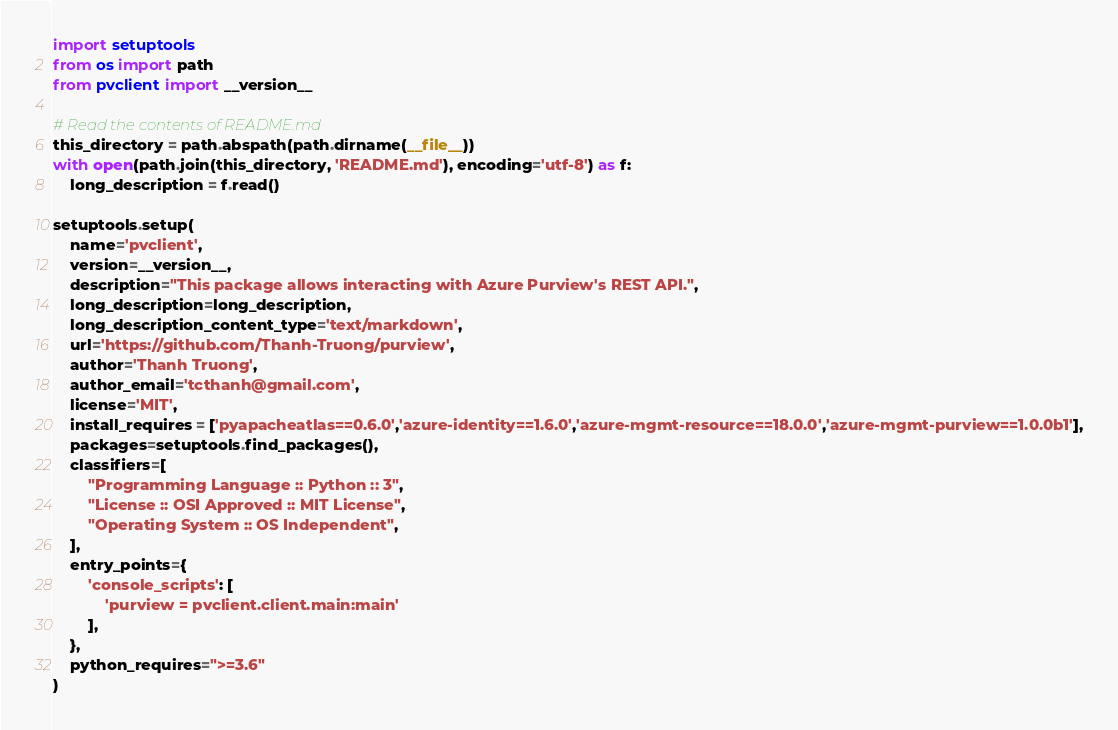<code> <loc_0><loc_0><loc_500><loc_500><_Python_>import setuptools
from os import path
from pvclient import __version__

# Read the contents of README.md
this_directory = path.abspath(path.dirname(__file__))
with open(path.join(this_directory, 'README.md'), encoding='utf-8') as f:
    long_description = f.read()

setuptools.setup(
    name='pvclient',
    version=__version__,
    description="This package allows interacting with Azure Purview's REST API.",
    long_description=long_description,
    long_description_content_type='text/markdown',
    url='https://github.com/Thanh-Truong/purview',
    author='Thanh Truong',
    author_email='tcthanh@gmail.com',
    license='MIT',
    install_requires = ['pyapacheatlas==0.6.0','azure-identity==1.6.0','azure-mgmt-resource==18.0.0','azure-mgmt-purview==1.0.0b1'],
    packages=setuptools.find_packages(),
    classifiers=[
        "Programming Language :: Python :: 3",
        "License :: OSI Approved :: MIT License",
        "Operating System :: OS Independent",
    ],
    entry_points={
        'console_scripts': [
            'purview = pvclient.client.main:main'
        ],
    },
    python_requires=">=3.6"
)</code> 